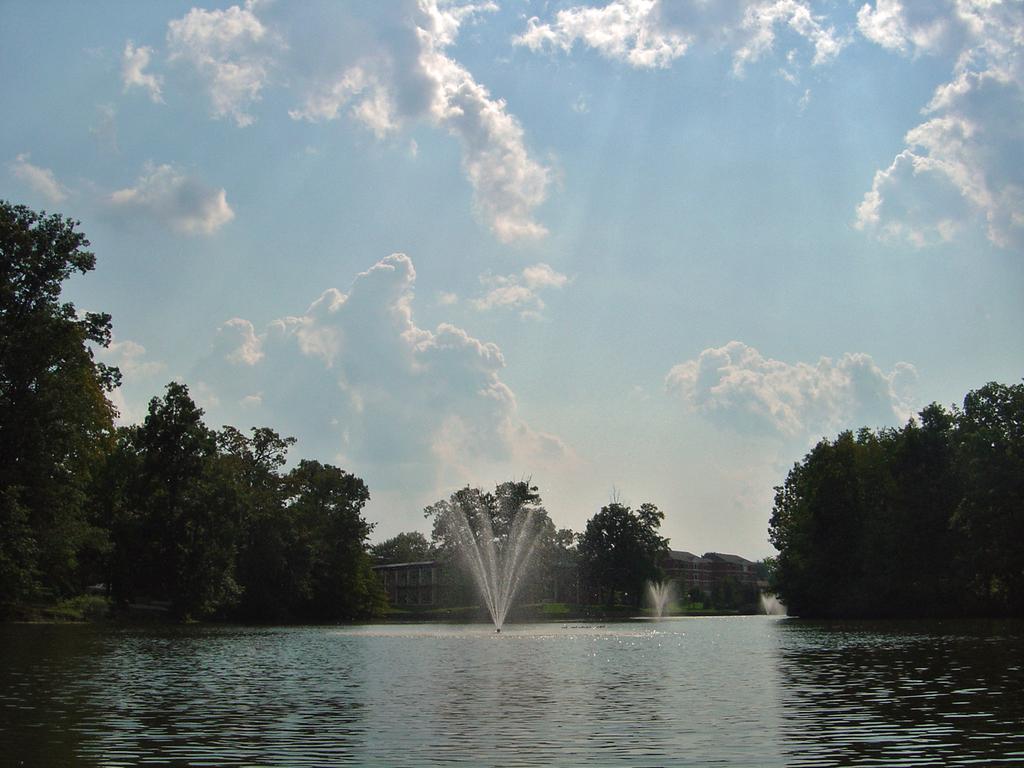Describe this image in one or two sentences. In the center of the image there is water. There are fountains. In the background of the image there are trees, buildings and sky. 